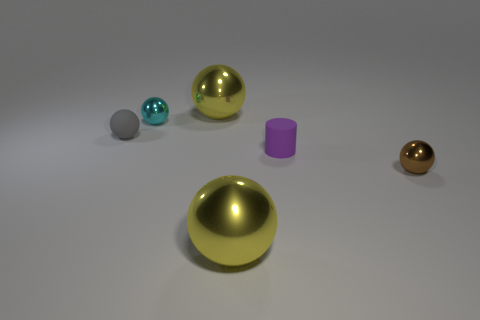The tiny ball that is both in front of the tiny cyan thing and left of the purple cylinder is what color?
Keep it short and to the point. Gray. There is a yellow object that is in front of the tiny matte sphere; what is it made of?
Your answer should be compact. Metal. What is the size of the purple matte thing?
Make the answer very short. Small. How many gray things are either tiny balls or large metallic balls?
Provide a succinct answer. 1. There is a gray ball behind the small metallic ball on the right side of the cylinder; how big is it?
Provide a short and direct response. Small. What number of other things are there of the same material as the cylinder
Keep it short and to the point. 1. What is the shape of the gray thing that is made of the same material as the tiny purple object?
Provide a succinct answer. Sphere. Are there more yellow things that are in front of the tiny gray rubber sphere than blocks?
Provide a succinct answer. Yes. There is a tiny cyan metal object; is it the same shape as the small purple object in front of the gray sphere?
Keep it short and to the point. No. What number of other balls have the same size as the gray matte sphere?
Provide a short and direct response. 2. 